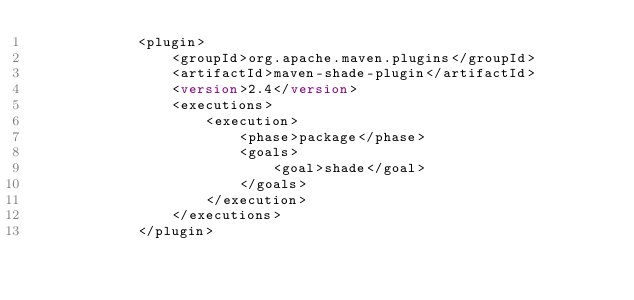Convert code to text. <code><loc_0><loc_0><loc_500><loc_500><_XML_>            <plugin>
                <groupId>org.apache.maven.plugins</groupId>
                <artifactId>maven-shade-plugin</artifactId>
                <version>2.4</version>
                <executions>
                    <execution>
                        <phase>package</phase>
                        <goals>
                            <goal>shade</goal>
                        </goals>
                    </execution>
                </executions>
            </plugin></code> 